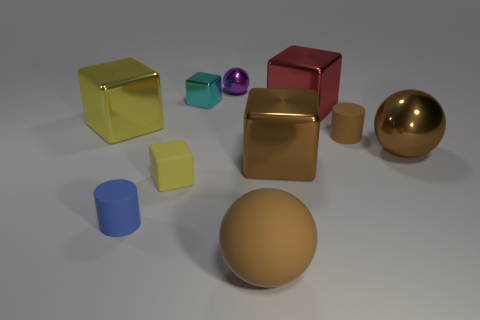Subtract 2 blocks. How many blocks are left? 3 Subtract all brown cubes. How many cubes are left? 4 Subtract all tiny yellow blocks. How many blocks are left? 4 Subtract all green cubes. Subtract all red spheres. How many cubes are left? 5 Subtract all balls. How many objects are left? 7 Add 4 large yellow shiny things. How many large yellow shiny things are left? 5 Add 6 red metal objects. How many red metal objects exist? 7 Subtract 1 yellow cubes. How many objects are left? 9 Subtract all big yellow things. Subtract all tiny brown metallic objects. How many objects are left? 9 